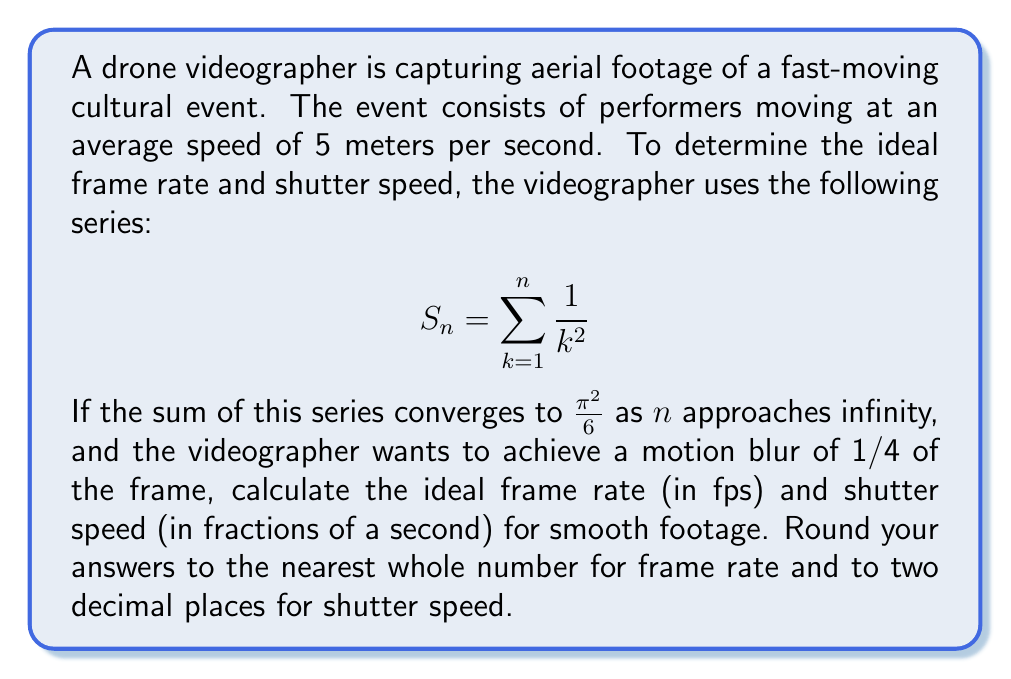Can you solve this math problem? To solve this problem, we'll follow these steps:

1) First, we need to understand the relationship between frame rate, shutter speed, and motion blur:
   - Motion blur = (Subject speed × Shutter speed) / Frame size

2) We're given that the desired motion blur is 1/4 of the frame. Let's express this as an equation:
   $$\frac{1}{4} = \frac{5 \text{ m/s} \times \text{Shutter speed}}{\text{Frame size}}$$

3) To find the frame size, we can use the series convergence information:
   $$\lim_{n \to \infty} S_n = \frac{\pi^2}{6} \approx 1.6449$$

   This value represents the total distance covered by the subject in one second, in frame units.

4) Now we can solve for the shutter speed:
   $$\text{Shutter speed} = \frac{1}{4} \times \frac{1.6449}{5} \approx 0.0822 \text{ seconds}$$

5) To calculate the frame rate, we use the inverse of the series sum:
   $$\text{Frame rate} = \frac{1}{1.6449} \times 60 \approx 36.48 \text{ fps}$$

6) Rounding to the nearest whole number for frame rate and two decimal places for shutter speed:
   - Frame rate ≈ 36 fps
   - Shutter speed ≈ 0.08 seconds (which can be expressed as 1/12.5)
Answer: 36 fps, 1/12.5 s 